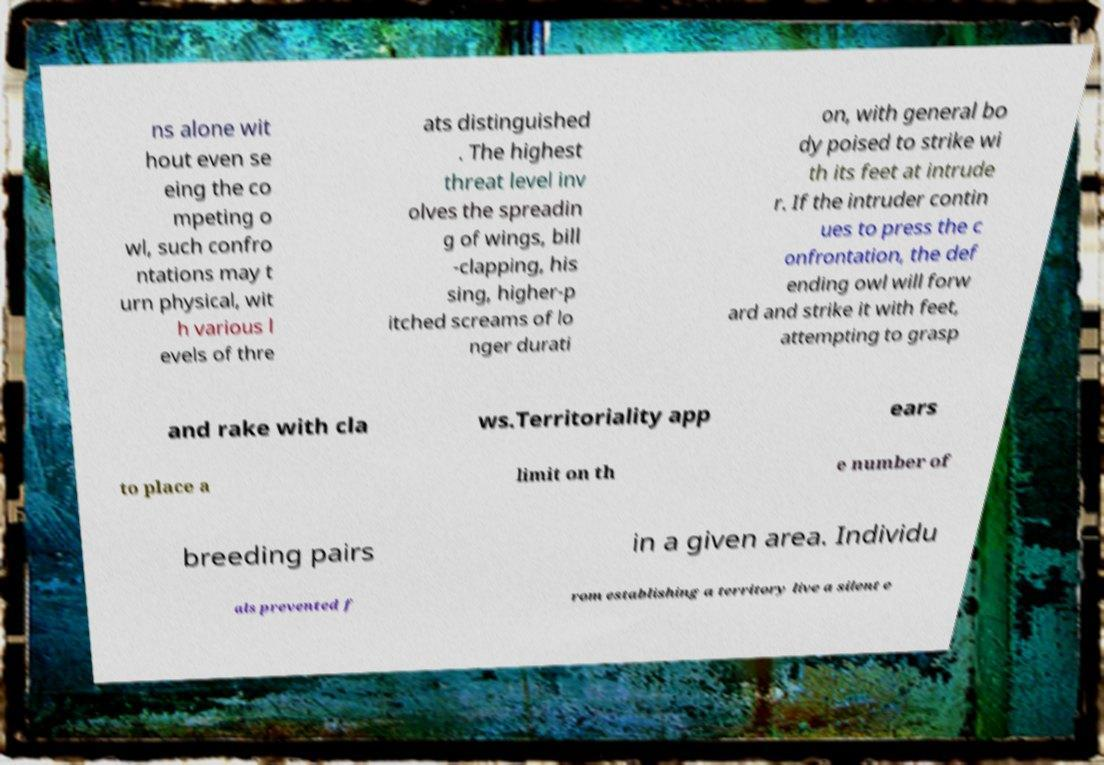Can you accurately transcribe the text from the provided image for me? ns alone wit hout even se eing the co mpeting o wl, such confro ntations may t urn physical, wit h various l evels of thre ats distinguished . The highest threat level inv olves the spreadin g of wings, bill -clapping, his sing, higher-p itched screams of lo nger durati on, with general bo dy poised to strike wi th its feet at intrude r. If the intruder contin ues to press the c onfrontation, the def ending owl will forw ard and strike it with feet, attempting to grasp and rake with cla ws.Territoriality app ears to place a limit on th e number of breeding pairs in a given area. Individu als prevented f rom establishing a territory live a silent e 